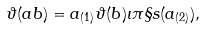Convert formula to latex. <formula><loc_0><loc_0><loc_500><loc_500>\vartheta ( a b ) = a _ { ( 1 ) } \vartheta ( b ) \iota \pi \S s ( a _ { ( 2 ) } ) ,</formula> 